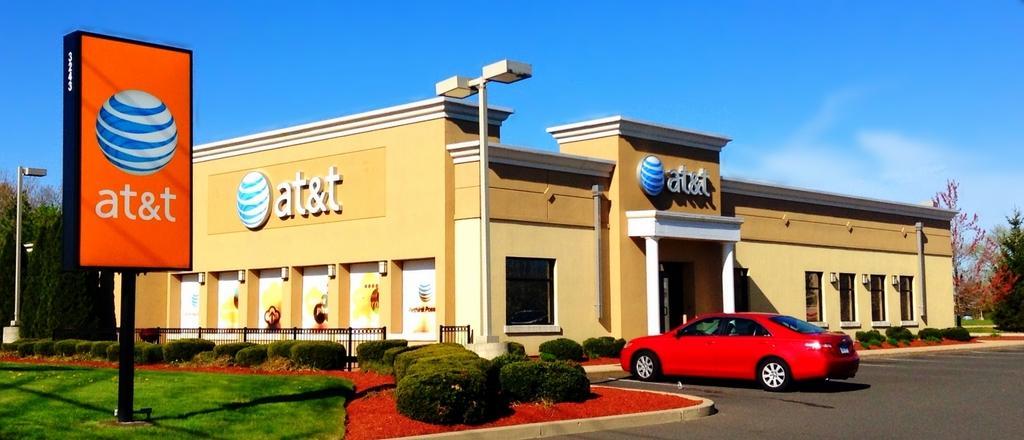Could you give a brief overview of what you see in this image? In this image at front there is a building. In front of the building there is a car. Beside the building we can see metal fence, plants. At the left side of the image there is grass on the surface. We can see board, street light, trees. At the top there is sky. 